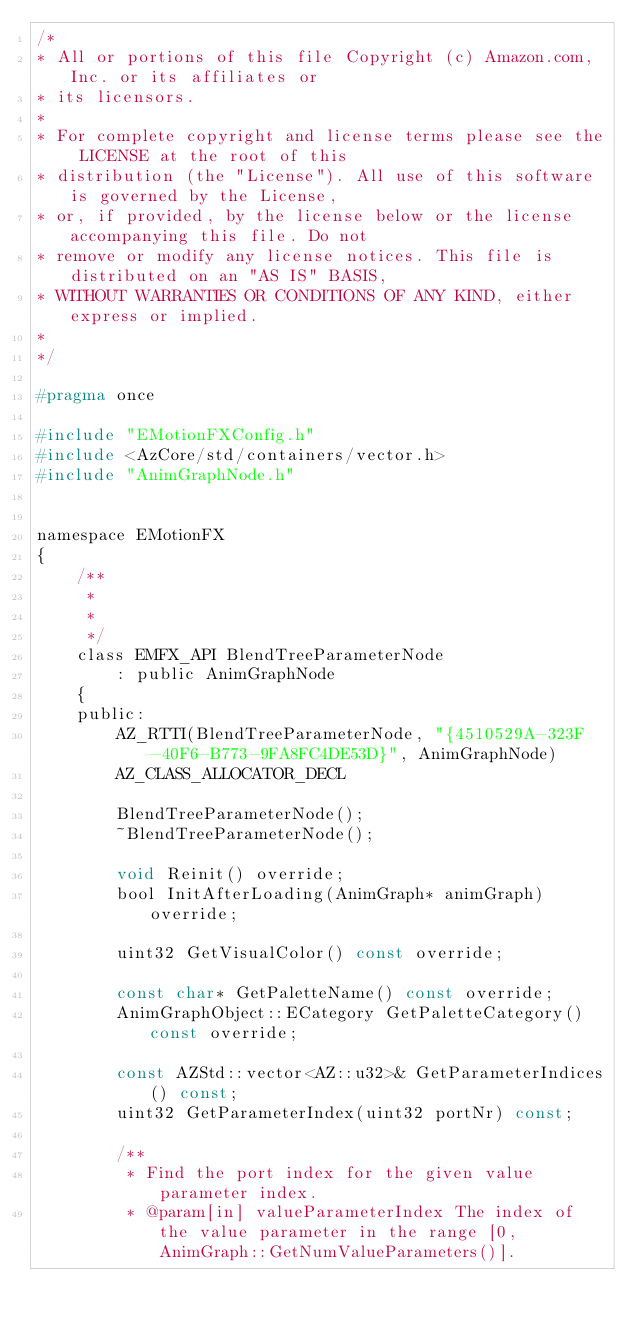Convert code to text. <code><loc_0><loc_0><loc_500><loc_500><_C_>/*
* All or portions of this file Copyright (c) Amazon.com, Inc. or its affiliates or
* its licensors.
*
* For complete copyright and license terms please see the LICENSE at the root of this
* distribution (the "License"). All use of this software is governed by the License,
* or, if provided, by the license below or the license accompanying this file. Do not
* remove or modify any license notices. This file is distributed on an "AS IS" BASIS,
* WITHOUT WARRANTIES OR CONDITIONS OF ANY KIND, either express or implied.
*
*/

#pragma once

#include "EMotionFXConfig.h"
#include <AzCore/std/containers/vector.h>
#include "AnimGraphNode.h"


namespace EMotionFX
{
    /**
     *
     *
     */
    class EMFX_API BlendTreeParameterNode
        : public AnimGraphNode
    {
    public:
        AZ_RTTI(BlendTreeParameterNode, "{4510529A-323F-40F6-B773-9FA8FC4DE53D}", AnimGraphNode)
        AZ_CLASS_ALLOCATOR_DECL

        BlendTreeParameterNode();
        ~BlendTreeParameterNode();

        void Reinit() override;
        bool InitAfterLoading(AnimGraph* animGraph) override;
        
        uint32 GetVisualColor() const override;

        const char* GetPaletteName() const override;
        AnimGraphObject::ECategory GetPaletteCategory() const override;

        const AZStd::vector<AZ::u32>& GetParameterIndices() const;
        uint32 GetParameterIndex(uint32 portNr) const;

        /**
         * Find the port index for the given value parameter index.
         * @param[in] valueParameterIndex The index of the value parameter in the range [0, AnimGraph::GetNumValueParameters()].</code> 